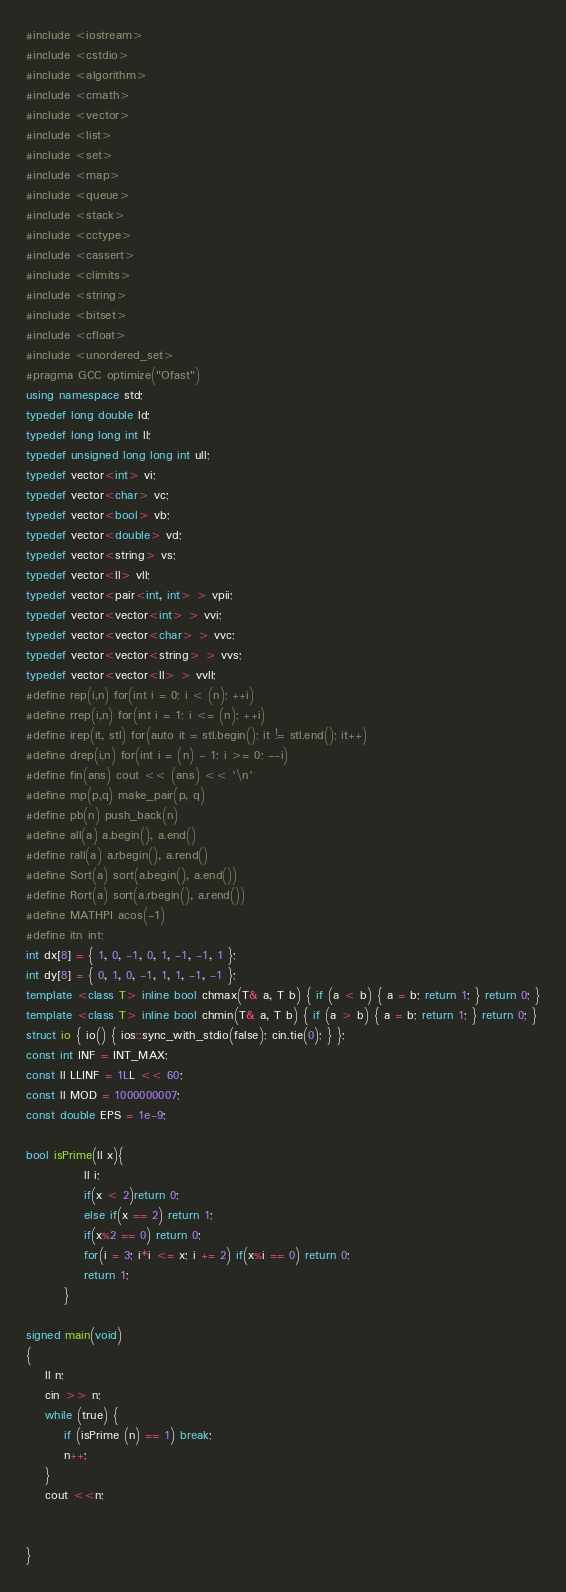Convert code to text. <code><loc_0><loc_0><loc_500><loc_500><_C++_>#include <iostream>
#include <cstdio>
#include <algorithm>
#include <cmath>
#include <vector>
#include <list>
#include <set>
#include <map>
#include <queue>
#include <stack>
#include <cctype>
#include <cassert>
#include <climits>
#include <string>
#include <bitset>
#include <cfloat>
#include <unordered_set>
#pragma GCC optimize("Ofast")
using namespace std;
typedef long double ld;
typedef long long int ll;
typedef unsigned long long int ull;
typedef vector<int> vi;
typedef vector<char> vc;
typedef vector<bool> vb;
typedef vector<double> vd;
typedef vector<string> vs;
typedef vector<ll> vll;
typedef vector<pair<int, int> > vpii;
typedef vector<vector<int> > vvi;
typedef vector<vector<char> > vvc;
typedef vector<vector<string> > vvs;
typedef vector<vector<ll> > vvll;
#define rep(i,n) for(int i = 0; i < (n); ++i)
#define rrep(i,n) for(int i = 1; i <= (n); ++i)
#define irep(it, stl) for(auto it = stl.begin(); it != stl.end(); it++)
#define drep(i,n) for(int i = (n) - 1; i >= 0; --i)
#define fin(ans) cout << (ans) << '\n'
#define mp(p,q) make_pair(p, q)
#define pb(n) push_back(n)
#define all(a) a.begin(), a.end()
#define rall(a) a.rbegin(), a.rend()
#define Sort(a) sort(a.begin(), a.end())
#define Rort(a) sort(a.rbegin(), a.rend())
#define MATHPI acos(-1)
#define itn int;
int dx[8] = { 1, 0, -1, 0, 1, -1, -1, 1 };
int dy[8] = { 0, 1, 0, -1, 1, 1, -1, -1 };
template <class T> inline bool chmax(T& a, T b) { if (a < b) { a = b; return 1; } return 0; }
template <class T> inline bool chmin(T& a, T b) { if (a > b) { a = b; return 1; } return 0; }
struct io { io() { ios::sync_with_stdio(false); cin.tie(0); } };
const int INF = INT_MAX;
const ll LLINF = 1LL << 60;
const ll MOD = 1000000007;
const double EPS = 1e-9;

bool isPrime(ll x){
            ll i;
            if(x < 2)return 0;
            else if(x == 2) return 1;
            if(x%2 == 0) return 0;
            for(i = 3; i*i <= x; i += 2) if(x%i == 0) return 0;
            return 1;
        }

signed main(void) 
{
    ll n;
    cin >> n;
    while (true) {
        if (isPrime (n) == 1) break;
        n++;
    }
    cout <<n;
    
   
}
</code> 